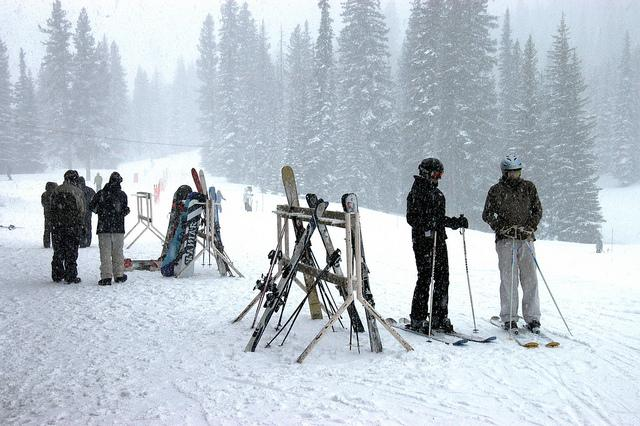What could potentially impede their vision shortly?

Choices:
A) snow storm
B) skiers
C) goggles
D) sun snow storm 